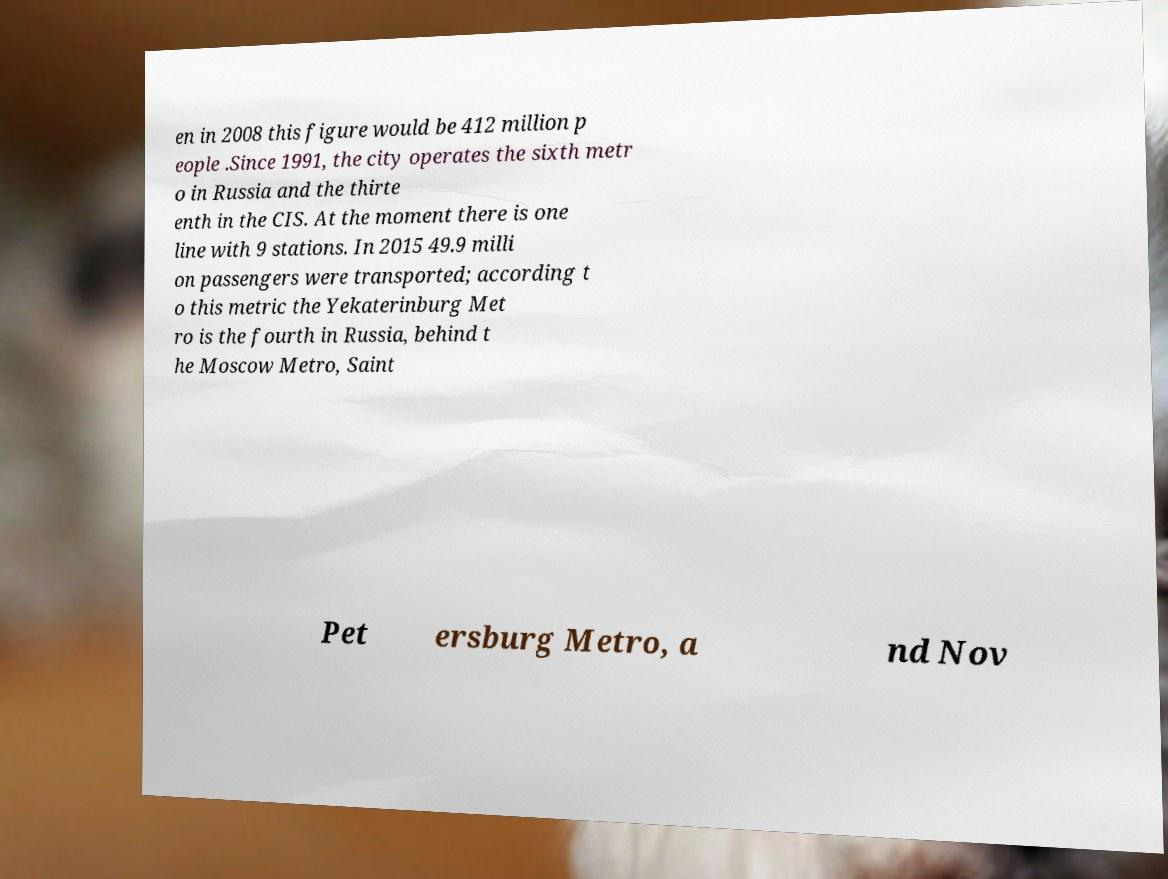Please read and relay the text visible in this image. What does it say? en in 2008 this figure would be 412 million p eople .Since 1991, the city operates the sixth metr o in Russia and the thirte enth in the CIS. At the moment there is one line with 9 stations. In 2015 49.9 milli on passengers were transported; according t o this metric the Yekaterinburg Met ro is the fourth in Russia, behind t he Moscow Metro, Saint Pet ersburg Metro, a nd Nov 